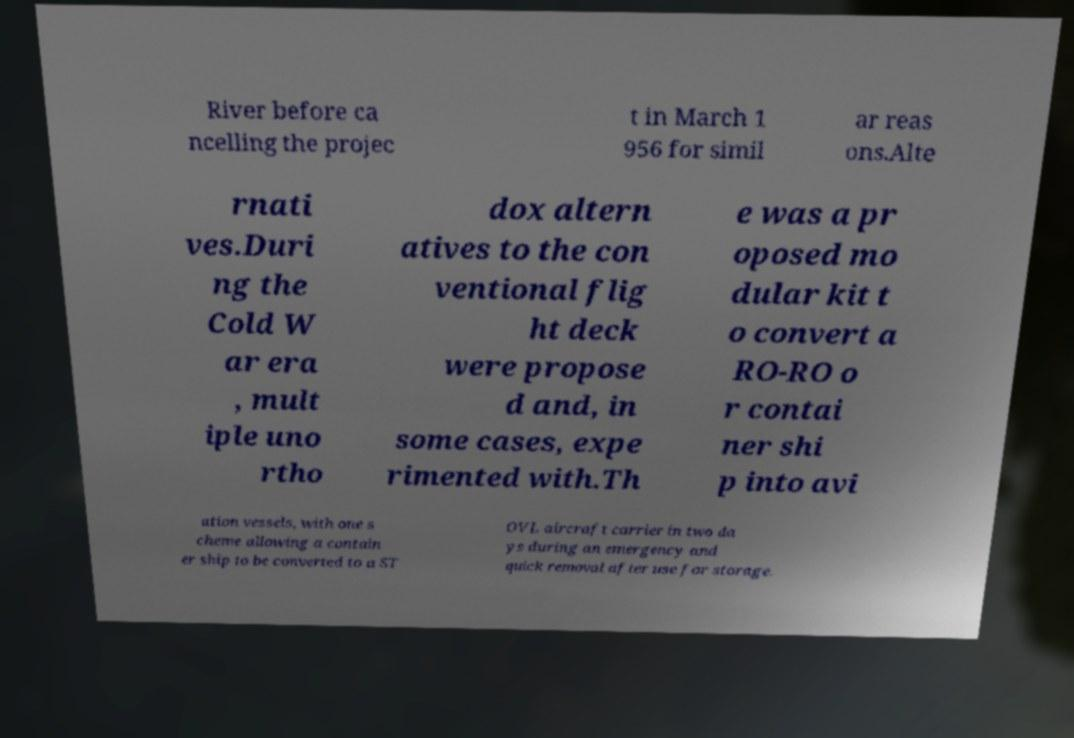Please read and relay the text visible in this image. What does it say? River before ca ncelling the projec t in March 1 956 for simil ar reas ons.Alte rnati ves.Duri ng the Cold W ar era , mult iple uno rtho dox altern atives to the con ventional flig ht deck were propose d and, in some cases, expe rimented with.Th e was a pr oposed mo dular kit t o convert a RO-RO o r contai ner shi p into avi ation vessels, with one s cheme allowing a contain er ship to be converted to a ST OVL aircraft carrier in two da ys during an emergency and quick removal after use for storage. 